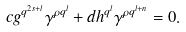Convert formula to latex. <formula><loc_0><loc_0><loc_500><loc_500>c g ^ { q ^ { 2 s + l } } \gamma ^ { \rho q ^ { l } } + d h ^ { q ^ { l } } \gamma ^ { \rho q ^ { l + n } } = 0 .</formula> 